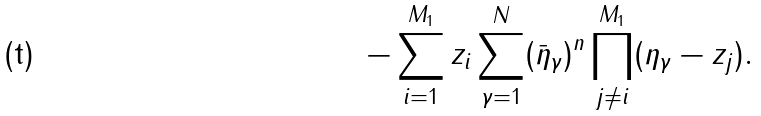Convert formula to latex. <formula><loc_0><loc_0><loc_500><loc_500>- \sum _ { i = 1 } ^ { M _ { 1 } } z _ { i } \sum ^ { N } _ { \gamma = 1 } ( \bar { \eta } _ { \gamma } ) ^ { n } \prod ^ { M _ { 1 } } _ { j \neq i } ( \eta _ { \gamma } - z _ { j } ) .</formula> 